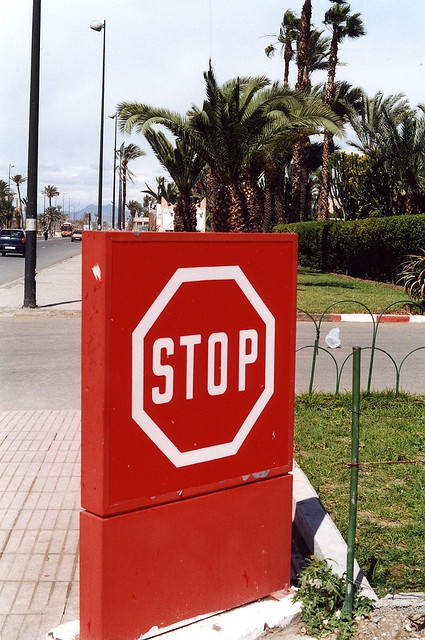Describe the objects in this image and their specific colors. I can see stop sign in white, brown, lightgray, and red tones, car in white, black, and gray tones, and car in white, black, maroon, gray, and tan tones in this image. 